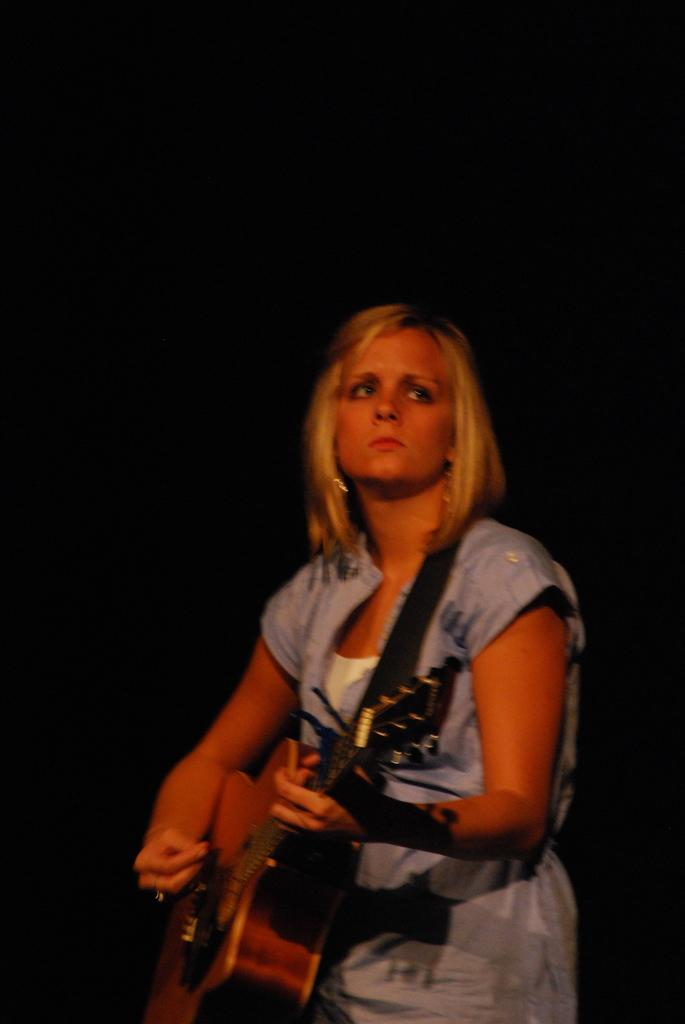What is the main subject of the image? The main subject of the image is a woman. What is the woman doing in the image? The woman is standing and playing a guitar. What type of scarf is the woman wearing in the image? There is no scarf visible in the image. Who is coaching the woman in the image? There is no coach present in the image. 